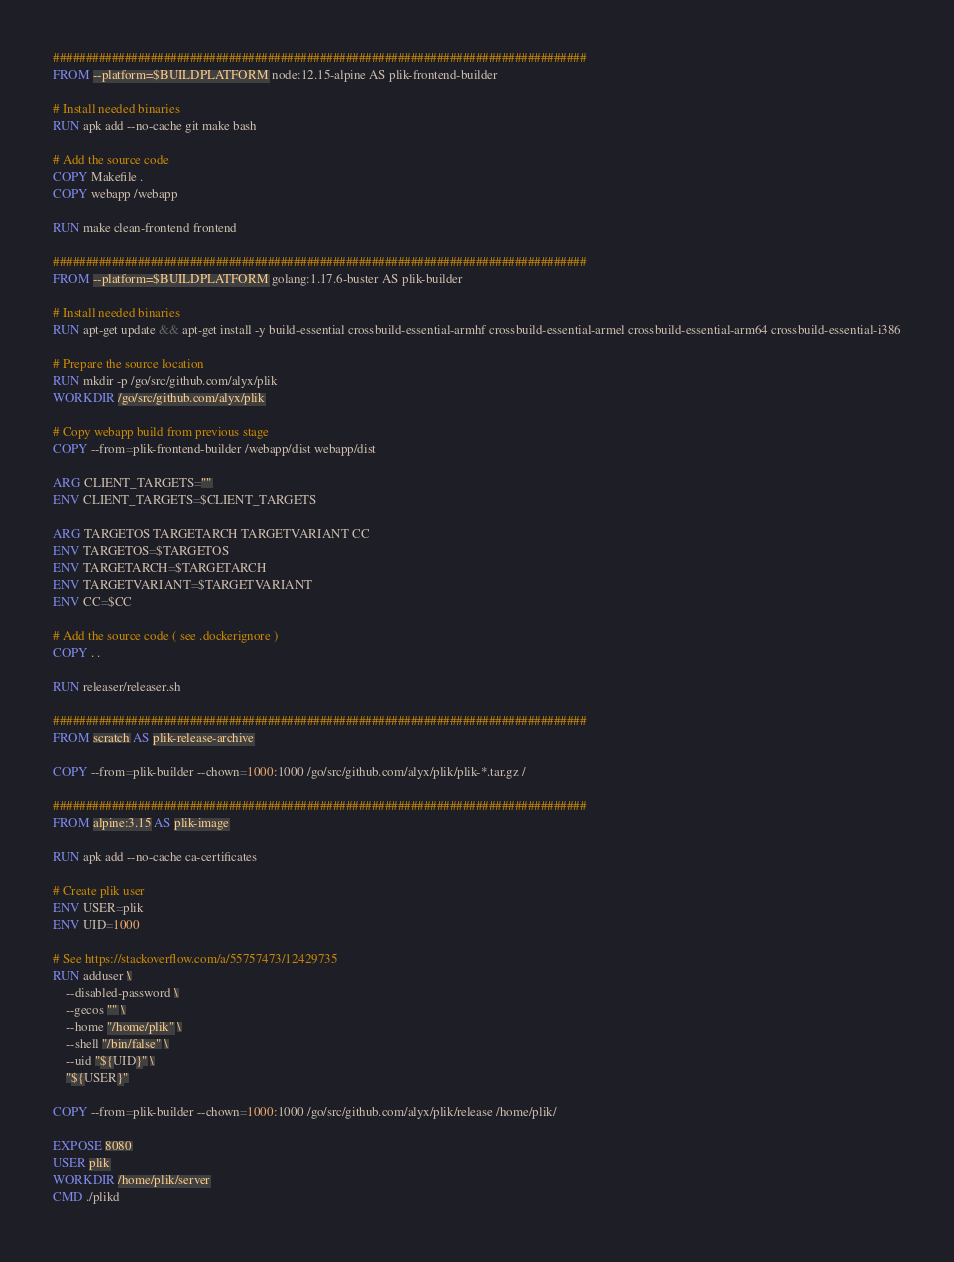Convert code to text. <code><loc_0><loc_0><loc_500><loc_500><_Dockerfile_>##################################################################################
FROM --platform=$BUILDPLATFORM node:12.15-alpine AS plik-frontend-builder

# Install needed binaries
RUN apk add --no-cache git make bash

# Add the source code
COPY Makefile .
COPY webapp /webapp

RUN make clean-frontend frontend

##################################################################################
FROM --platform=$BUILDPLATFORM golang:1.17.6-buster AS plik-builder

# Install needed binaries
RUN apt-get update && apt-get install -y build-essential crossbuild-essential-armhf crossbuild-essential-armel crossbuild-essential-arm64 crossbuild-essential-i386

# Prepare the source location
RUN mkdir -p /go/src/github.com/alyx/plik
WORKDIR /go/src/github.com/alyx/plik

# Copy webapp build from previous stage
COPY --from=plik-frontend-builder /webapp/dist webapp/dist

ARG CLIENT_TARGETS=""
ENV CLIENT_TARGETS=$CLIENT_TARGETS

ARG TARGETOS TARGETARCH TARGETVARIANT CC
ENV TARGETOS=$TARGETOS
ENV TARGETARCH=$TARGETARCH
ENV TARGETVARIANT=$TARGETVARIANT
ENV CC=$CC

# Add the source code ( see .dockerignore )
COPY . .

RUN releaser/releaser.sh

##################################################################################
FROM scratch AS plik-release-archive

COPY --from=plik-builder --chown=1000:1000 /go/src/github.com/alyx/plik/plik-*.tar.gz /

##################################################################################
FROM alpine:3.15 AS plik-image

RUN apk add --no-cache ca-certificates

# Create plik user
ENV USER=plik
ENV UID=1000

# See https://stackoverflow.com/a/55757473/12429735
RUN adduser \
    --disabled-password \
    --gecos "" \
    --home "/home/plik" \
    --shell "/bin/false" \
    --uid "${UID}" \
    "${USER}"

COPY --from=plik-builder --chown=1000:1000 /go/src/github.com/alyx/plik/release /home/plik/

EXPOSE 8080
USER plik
WORKDIR /home/plik/server
CMD ./plikd</code> 